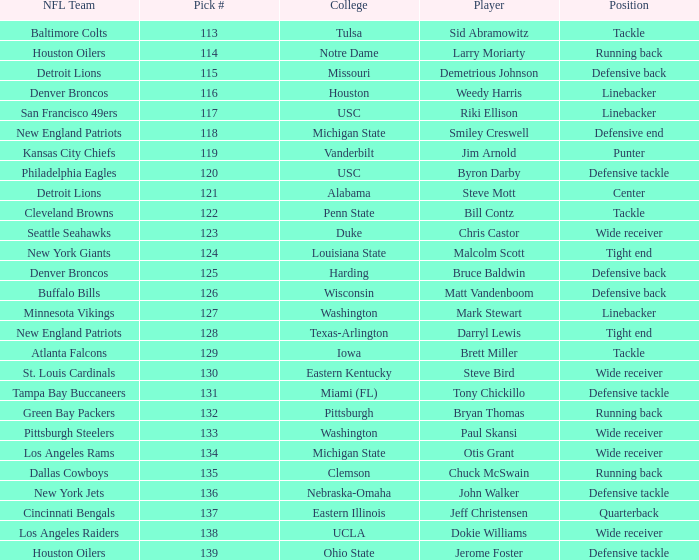Which player did the green bay packers pick? Bryan Thomas. 